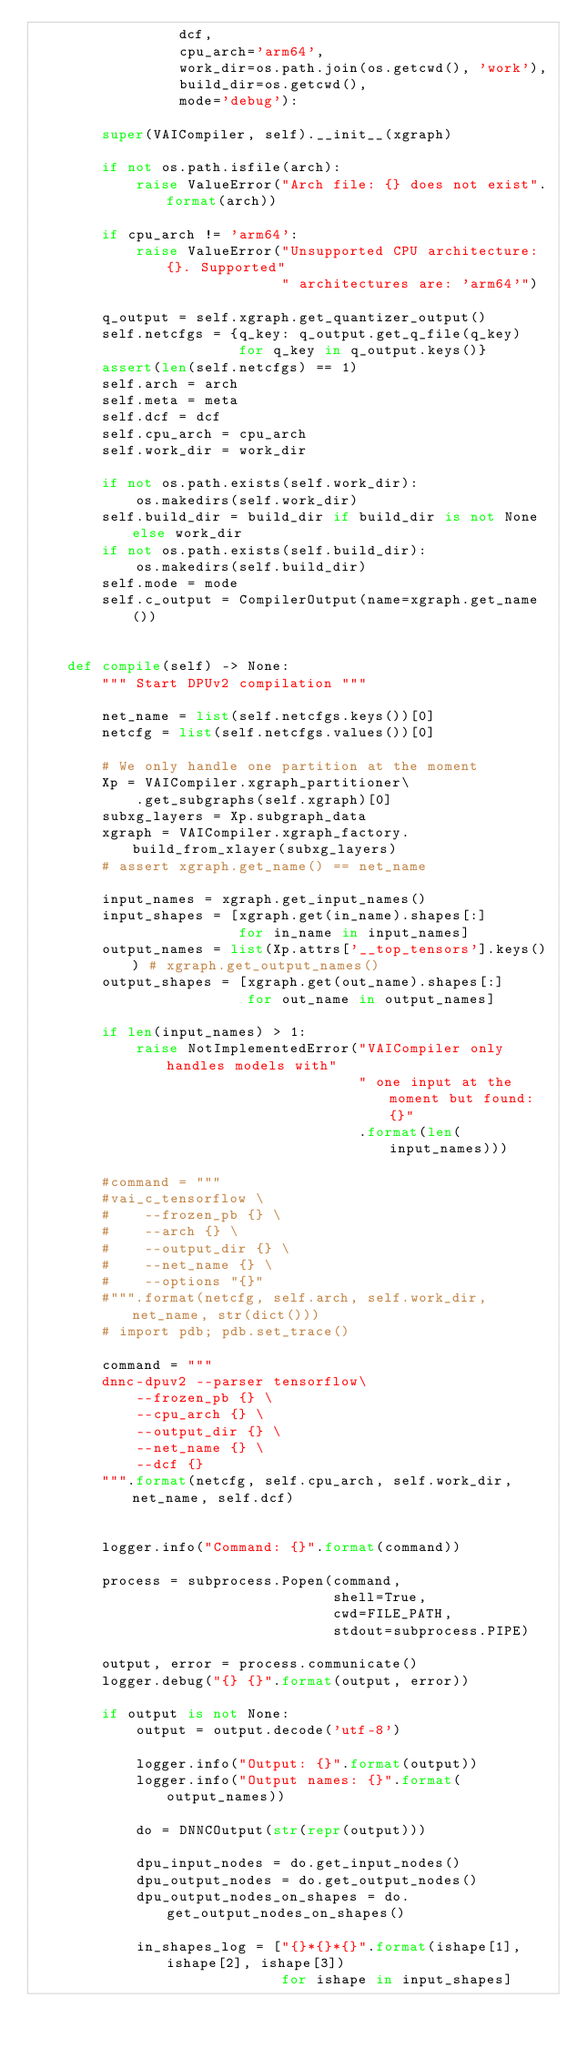<code> <loc_0><loc_0><loc_500><loc_500><_Python_>                 dcf,
                 cpu_arch='arm64',
                 work_dir=os.path.join(os.getcwd(), 'work'),
                 build_dir=os.getcwd(),
                 mode='debug'):

        super(VAICompiler, self).__init__(xgraph)

        if not os.path.isfile(arch):
            raise ValueError("Arch file: {} does not exist".format(arch))

        if cpu_arch != 'arm64':
            raise ValueError("Unsupported CPU architecture: {}. Supported"
                             " architectures are: 'arm64'")

        q_output = self.xgraph.get_quantizer_output()
        self.netcfgs = {q_key: q_output.get_q_file(q_key)
                        for q_key in q_output.keys()}
        assert(len(self.netcfgs) == 1)
        self.arch = arch
        self.meta = meta
        self.dcf = dcf
        self.cpu_arch = cpu_arch
        self.work_dir = work_dir

        if not os.path.exists(self.work_dir):
            os.makedirs(self.work_dir)
        self.build_dir = build_dir if build_dir is not None else work_dir
        if not os.path.exists(self.build_dir):
            os.makedirs(self.build_dir)
        self.mode = mode
        self.c_output = CompilerOutput(name=xgraph.get_name())
        

    def compile(self) -> None:
        """ Start DPUv2 compilation """

        net_name = list(self.netcfgs.keys())[0]
        netcfg = list(self.netcfgs.values())[0]

        # We only handle one partition at the moment
        Xp = VAICompiler.xgraph_partitioner\
            .get_subgraphs(self.xgraph)[0]
        subxg_layers = Xp.subgraph_data
        xgraph = VAICompiler.xgraph_factory.build_from_xlayer(subxg_layers)
        # assert xgraph.get_name() == net_name

        input_names = xgraph.get_input_names()
        input_shapes = [xgraph.get(in_name).shapes[:]
                        for in_name in input_names]
        output_names = list(Xp.attrs['__top_tensors'].keys()) # xgraph.get_output_names()
        output_shapes = [xgraph.get(out_name).shapes[:]
                         for out_name in output_names]

        if len(input_names) > 1:
            raise NotImplementedError("VAICompiler only handles models with"
                                      " one input at the moment but found: {}"
                                      .format(len(input_names)))

        #command = """
        #vai_c_tensorflow \
        #    --frozen_pb {} \
        #    --arch {} \
        #    --output_dir {} \
        #    --net_name {} \
        #    --options "{}"
        #""".format(netcfg, self.arch, self.work_dir, net_name, str(dict()))
        # import pdb; pdb.set_trace()

        command = """
        dnnc-dpuv2 --parser tensorflow\
            --frozen_pb {} \
            --cpu_arch {} \
            --output_dir {} \
            --net_name {} \
            --dcf {}
        """.format(netcfg, self.cpu_arch, self.work_dir, net_name, self.dcf)


        logger.info("Command: {}".format(command))

        process = subprocess.Popen(command,
                                   shell=True,
                                   cwd=FILE_PATH,
                                   stdout=subprocess.PIPE)

        output, error = process.communicate()
        logger.debug("{} {}".format(output, error))

        if output is not None:
            output = output.decode('utf-8')

            logger.info("Output: {}".format(output))
            logger.info("Output names: {}".format(output_names))

            do = DNNCOutput(str(repr(output)))

            dpu_input_nodes = do.get_input_nodes()
            dpu_output_nodes = do.get_output_nodes()
            dpu_output_nodes_on_shapes = do.get_output_nodes_on_shapes()

            in_shapes_log = ["{}*{}*{}".format(ishape[1], ishape[2], ishape[3])
                             for ishape in input_shapes]</code> 